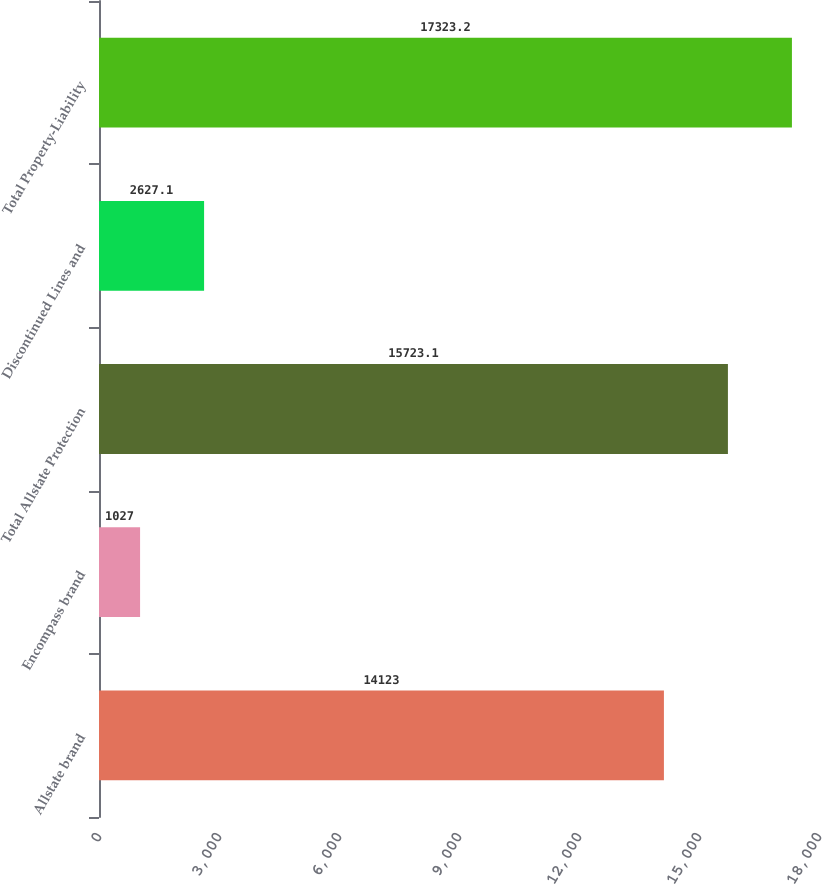Convert chart. <chart><loc_0><loc_0><loc_500><loc_500><bar_chart><fcel>Allstate brand<fcel>Encompass brand<fcel>Total Allstate Protection<fcel>Discontinued Lines and<fcel>Total Property-Liability<nl><fcel>14123<fcel>1027<fcel>15723.1<fcel>2627.1<fcel>17323.2<nl></chart> 